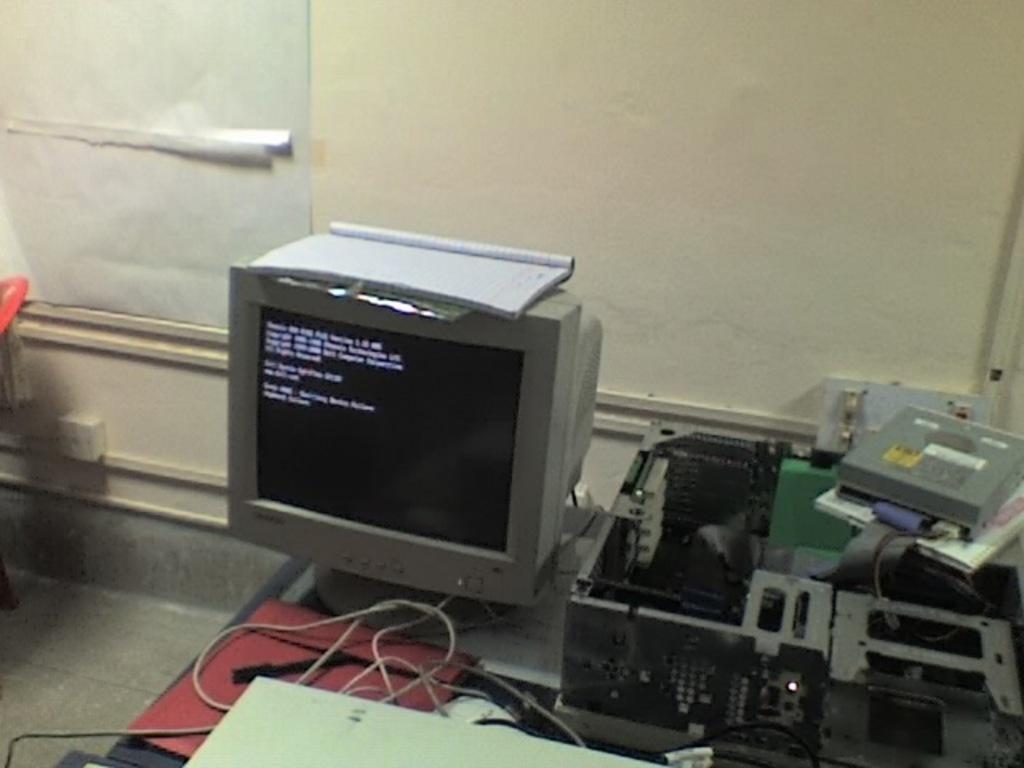Please provide a concise description of this image. In this image, we can see a screen with a book on it. We can also see some devices. We can also see some objects on the right. We can see the wall with some objects. We can also see the ground and some objects at the bottom. 